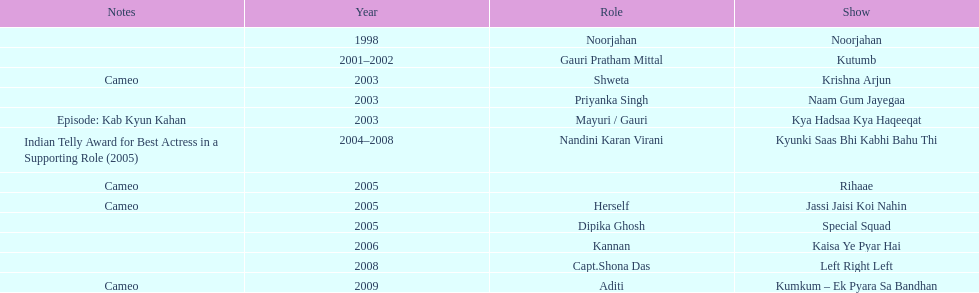The show above left right left Kaisa Ye Pyar Hai. 